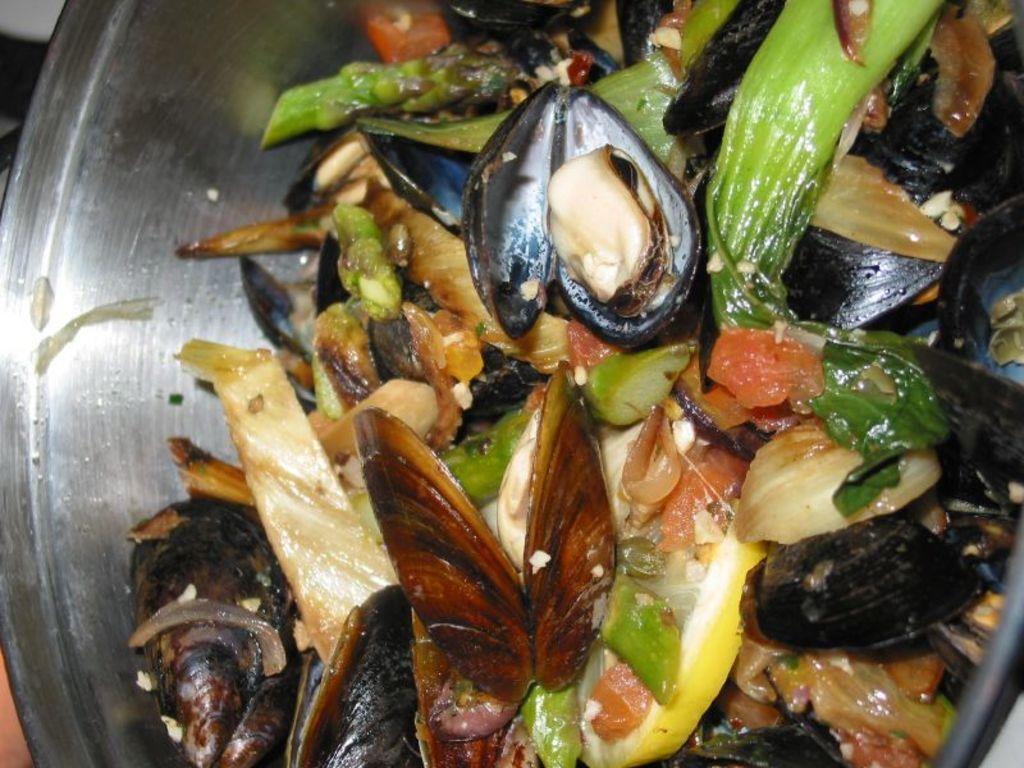In one or two sentences, can you explain what this image depicts? In this picture we can see food items in a bowl. 